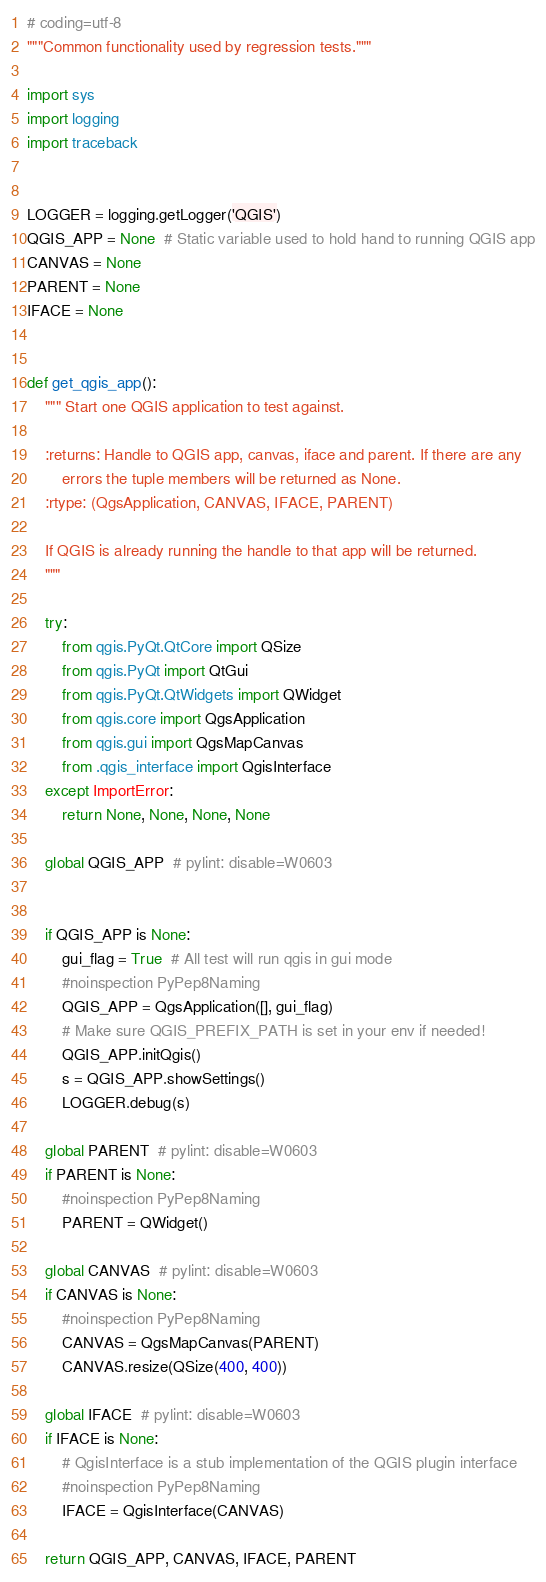Convert code to text. <code><loc_0><loc_0><loc_500><loc_500><_Python_># coding=utf-8
"""Common functionality used by regression tests."""

import sys
import logging
import traceback


LOGGER = logging.getLogger('QGIS')
QGIS_APP = None  # Static variable used to hold hand to running QGIS app
CANVAS = None
PARENT = None
IFACE = None


def get_qgis_app():
    """ Start one QGIS application to test against.

    :returns: Handle to QGIS app, canvas, iface and parent. If there are any
        errors the tuple members will be returned as None.
    :rtype: (QgsApplication, CANVAS, IFACE, PARENT)

    If QGIS is already running the handle to that app will be returned.
    """

    try:
        from qgis.PyQt.QtCore import QSize
        from qgis.PyQt import QtGui
        from qgis.PyQt.QtWidgets import QWidget
        from qgis.core import QgsApplication
        from qgis.gui import QgsMapCanvas
        from .qgis_interface import QgisInterface
    except ImportError:
        return None, None, None, None

    global QGIS_APP  # pylint: disable=W0603

    
    if QGIS_APP is None:
        gui_flag = True  # All test will run qgis in gui mode
        #noinspection PyPep8Naming
        QGIS_APP = QgsApplication([], gui_flag)
        # Make sure QGIS_PREFIX_PATH is set in your env if needed!
        QGIS_APP.initQgis()
        s = QGIS_APP.showSettings()
        LOGGER.debug(s)

    global PARENT  # pylint: disable=W0603
    if PARENT is None:
        #noinspection PyPep8Naming
        PARENT = QWidget()

    global CANVAS  # pylint: disable=W0603
    if CANVAS is None:
        #noinspection PyPep8Naming
        CANVAS = QgsMapCanvas(PARENT)
        CANVAS.resize(QSize(400, 400))

    global IFACE  # pylint: disable=W0603
    if IFACE is None:
        # QgisInterface is a stub implementation of the QGIS plugin interface
        #noinspection PyPep8Naming
        IFACE = QgisInterface(CANVAS)

    return QGIS_APP, CANVAS, IFACE, PARENT
</code> 